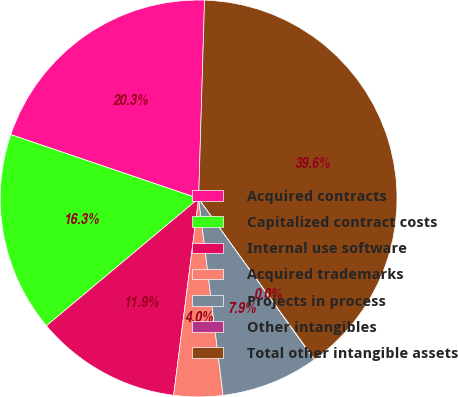Convert chart to OTSL. <chart><loc_0><loc_0><loc_500><loc_500><pie_chart><fcel>Acquired contracts<fcel>Capitalized contract costs<fcel>Internal use software<fcel>Acquired trademarks<fcel>Projects in process<fcel>Other intangibles<fcel>Total other intangible assets<nl><fcel>20.26%<fcel>16.31%<fcel>11.9%<fcel>3.98%<fcel>7.94%<fcel>0.03%<fcel>39.59%<nl></chart> 